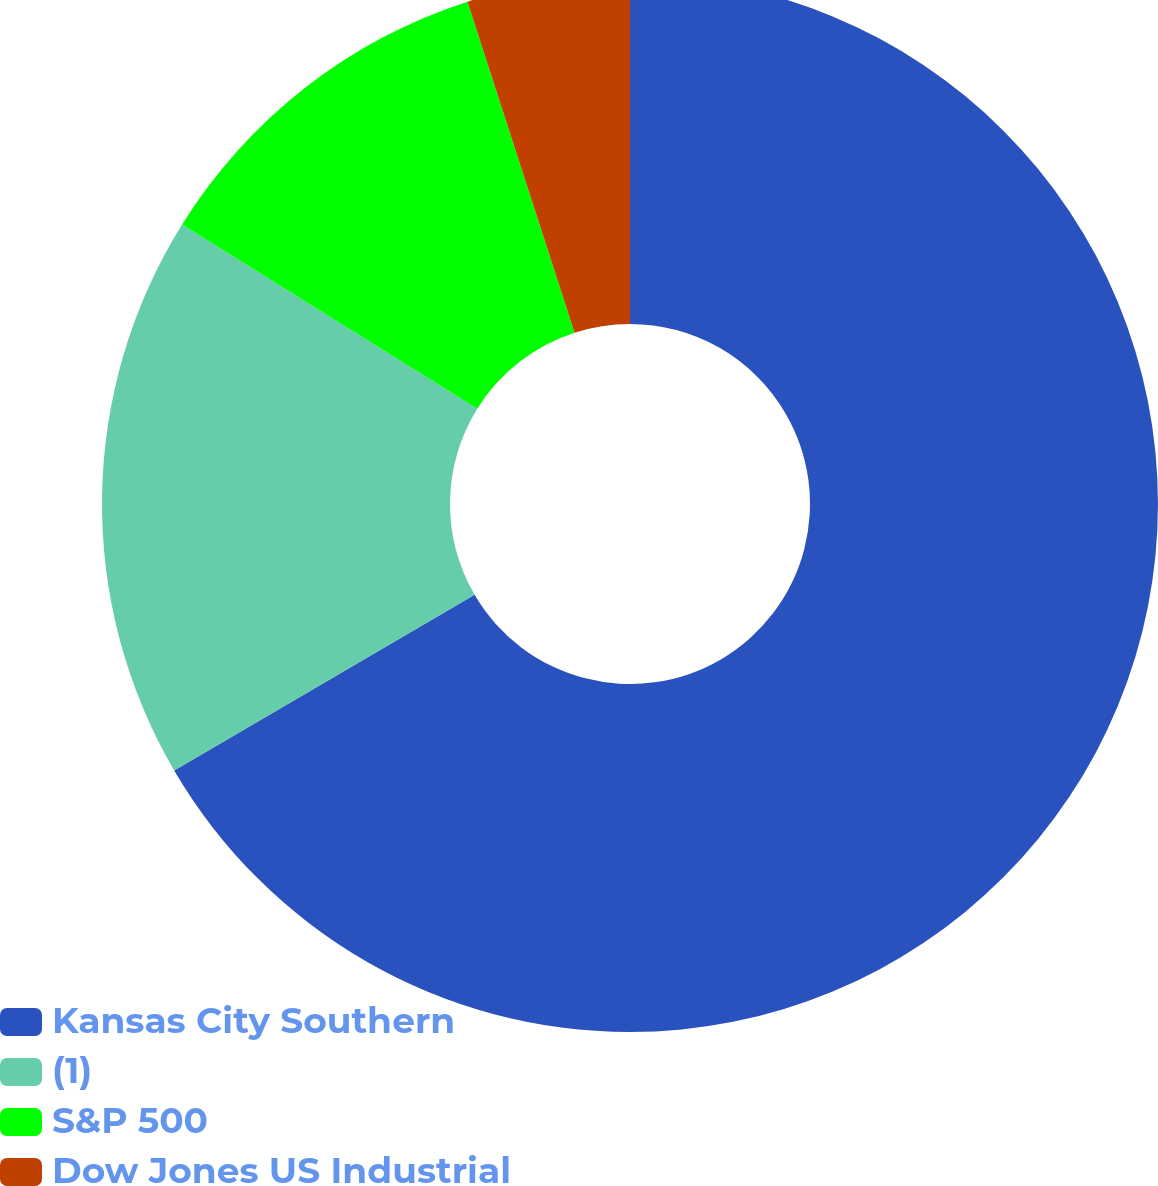Convert chart. <chart><loc_0><loc_0><loc_500><loc_500><pie_chart><fcel>Kansas City Southern<fcel>(1)<fcel>S&P 500<fcel>Dow Jones US Industrial<nl><fcel>66.58%<fcel>17.3%<fcel>11.14%<fcel>4.98%<nl></chart> 